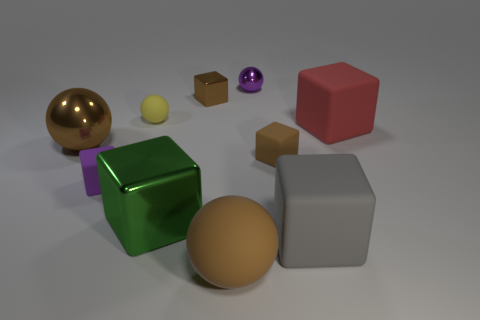There is a large brown thing left of the rubber sphere behind the tiny brown thing that is in front of the red thing; what is it made of?
Offer a very short reply. Metal. What number of other things are there of the same size as the yellow object?
Provide a short and direct response. 4. Does the small rubber ball have the same color as the big shiny ball?
Make the answer very short. No. How many large green shiny blocks are left of the rubber ball to the left of the matte sphere that is in front of the big gray matte cube?
Give a very brief answer. 0. The brown ball left of the brown cube behind the large metal sphere is made of what material?
Keep it short and to the point. Metal. Is there another rubber object that has the same shape as the yellow thing?
Offer a very short reply. Yes. The rubber ball that is the same size as the brown metallic block is what color?
Offer a very short reply. Yellow. What number of objects are brown things behind the tiny yellow rubber ball or tiny objects behind the purple rubber thing?
Make the answer very short. 4. How many things are either big green metal objects or red shiny cubes?
Provide a short and direct response. 1. What is the size of the thing that is behind the tiny brown rubber object and left of the small yellow matte sphere?
Keep it short and to the point. Large. 